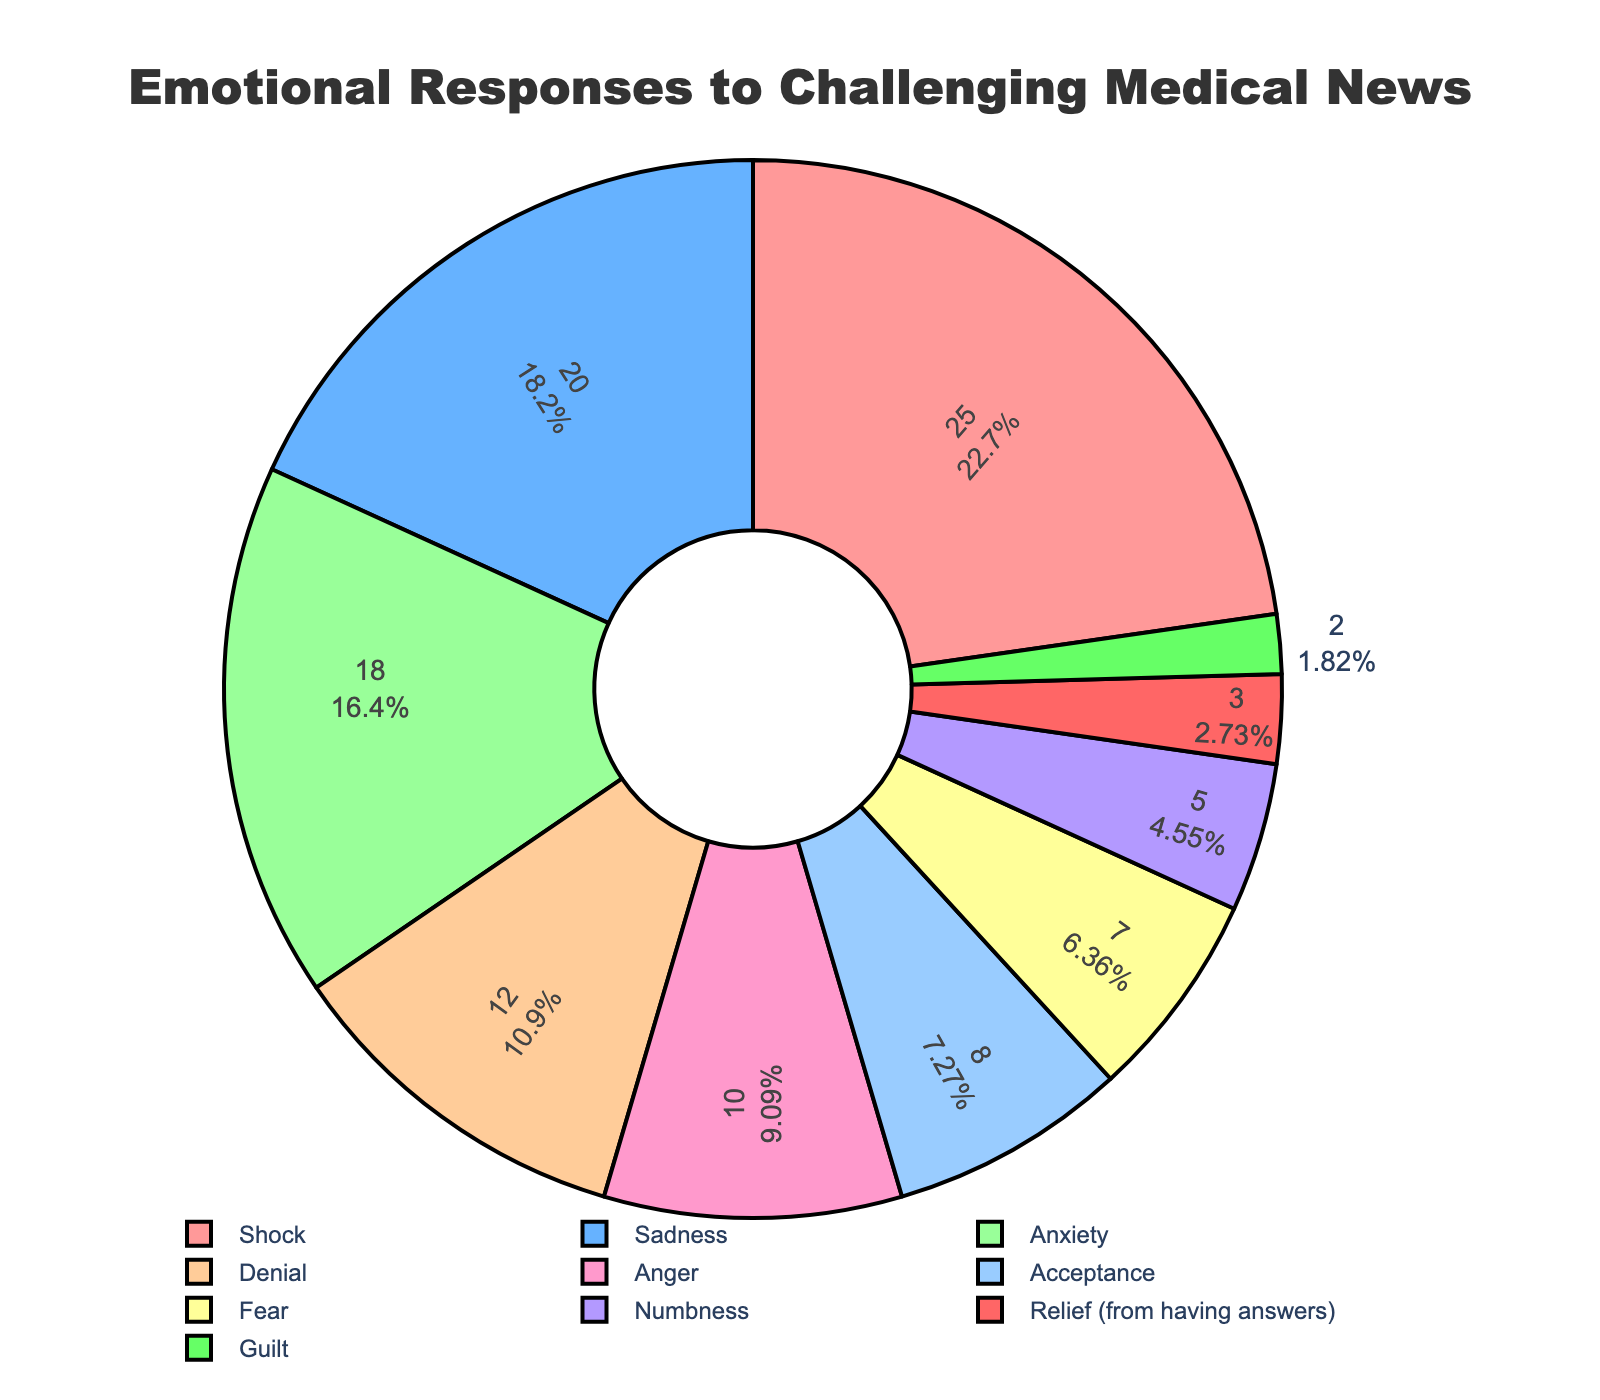What percentage of patients reported feeling Shock? To find the percentage of patients who reported feeling Shock, refer to the segment labeled 'Shock' in the pie chart. The chart indicates that this segment occupies 25% of the pie.
Answer: 25% Which emotional response had the second highest percentage? To determine the second highest percentage, look for the second largest segment in the pie chart after identifying the largest. The largest segment is Shock at 25%, followed by Sadness, which occupies 20%.
Answer: Sadness What is the combined percentage of patients who reported Anxiety, Denial, and Anger? To find the combined percentage, add the individual percentages of Anxiety (18%), Denial (12%), and Anger (10%). The sum is 18 + 12 + 10, which equals 40%.
Answer: 40% How many emotional responses have a percentage lower than 10%? Identify the segments with percentages less than 10%. These are Acceptance (8%), Fear (7%), Numbness (5%), Relief (3%), and Guilt (2%). There are 5 such segments.
Answer: 5 Is the percentage of patients reporting Acceptance higher or lower than those reporting Denial? Compare the two segments: Acceptance is 8% and Denial is 12%. Acceptance is lower than Denial.
Answer: Lower Which emotional response is represented by the smallest segment? The smallest segment corresponds to the smallest percentage value. Guilt has the smallest segment at 2%.
Answer: Guilt What is the difference in percentage between patients reporting Shock and those reporting Relief? Subtract the percentage of Relief (3%) from Shock (25%). The difference is 25 - 3, which equals 22%.
Answer: 22% Do more patients report Sadness or Anxiety? Compare the segments for Sadness and Anxiety. Sadness is 20%, and Anxiety is 18%. More patients report Sadness.
Answer: Sadness What is the sum of the percentages for the three most common emotional responses? Identify the top three segments, which are Shock (25%), Sadness (20%), and Anxiety (18%). Add these percentages together: 25 + 20 + 18 equals 63%.
Answer: 63% Among Fear, Numbness, and Relief, which has the highest percentage? Compare the segments for Fear (7%), Numbness (5%), and Relief (3%). Fear is the highest at 7%.
Answer: Fear 